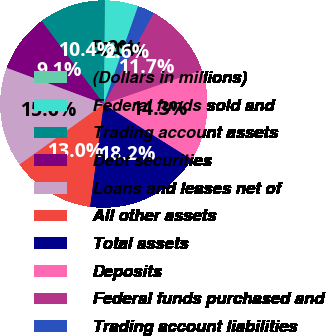Convert chart. <chart><loc_0><loc_0><loc_500><loc_500><pie_chart><fcel>(Dollars in millions)<fcel>Federal funds sold and<fcel>Trading account assets<fcel>Debt securities<fcel>Loans and leases net of<fcel>All other assets<fcel>Total assets<fcel>Deposits<fcel>Federal funds purchased and<fcel>Trading account liabilities<nl><fcel>0.02%<fcel>5.2%<fcel>10.39%<fcel>9.09%<fcel>15.58%<fcel>12.98%<fcel>18.17%<fcel>14.28%<fcel>11.69%<fcel>2.61%<nl></chart> 